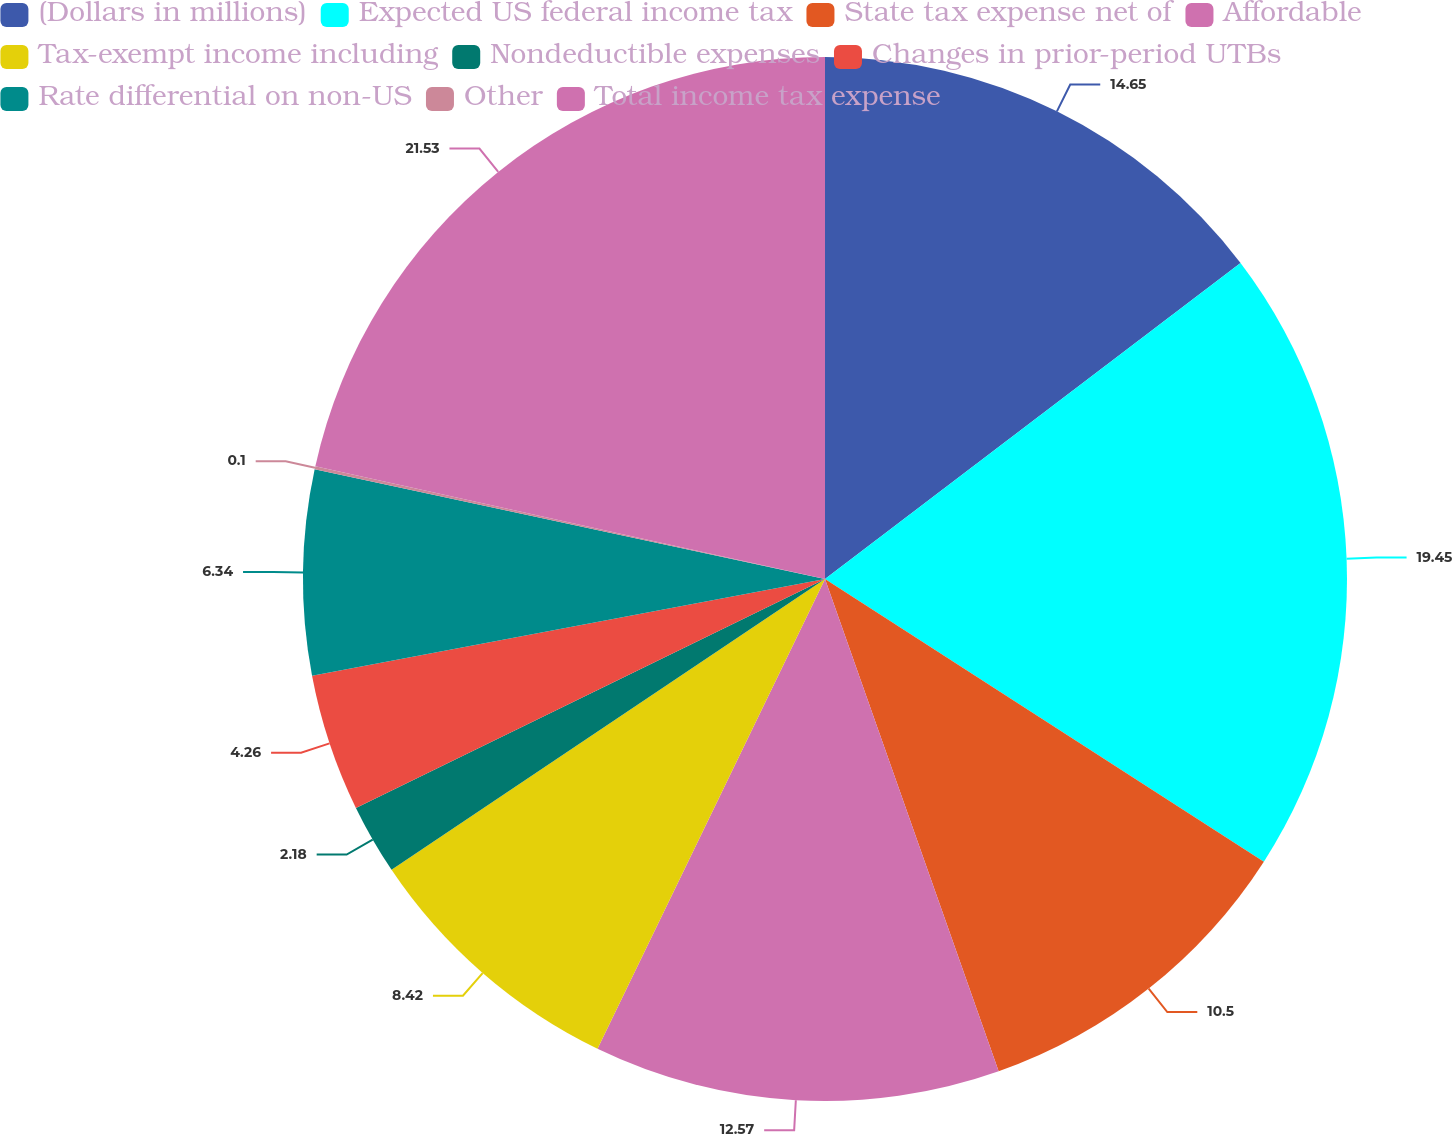<chart> <loc_0><loc_0><loc_500><loc_500><pie_chart><fcel>(Dollars in millions)<fcel>Expected US federal income tax<fcel>State tax expense net of<fcel>Affordable<fcel>Tax-exempt income including<fcel>Nondeductible expenses<fcel>Changes in prior-period UTBs<fcel>Rate differential on non-US<fcel>Other<fcel>Total income tax expense<nl><fcel>14.66%<fcel>19.46%<fcel>10.5%<fcel>12.58%<fcel>8.42%<fcel>2.18%<fcel>4.26%<fcel>6.34%<fcel>0.1%<fcel>21.54%<nl></chart> 